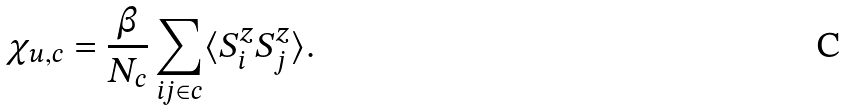<formula> <loc_0><loc_0><loc_500><loc_500>\chi _ { u , c } = \frac { \beta } { N _ { c } } \sum _ { i j \in c } \langle S _ { i } ^ { z } S _ { j } ^ { z } \rangle .</formula> 